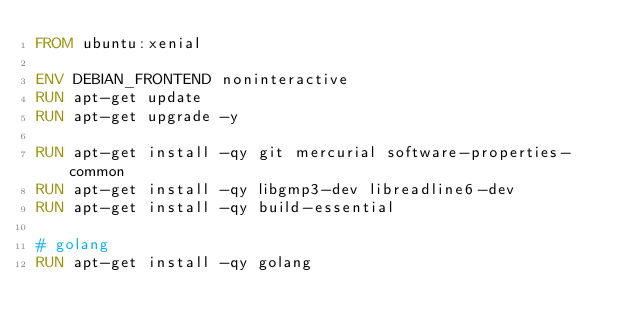Convert code to text. <code><loc_0><loc_0><loc_500><loc_500><_Dockerfile_>FROM ubuntu:xenial

ENV DEBIAN_FRONTEND noninteractive
RUN apt-get update
RUN apt-get upgrade -y

RUN apt-get install -qy git mercurial software-properties-common
RUN apt-get install -qy libgmp3-dev libreadline6-dev
RUN apt-get install -qy build-essential

# golang
RUN apt-get install -qy golang
</code> 